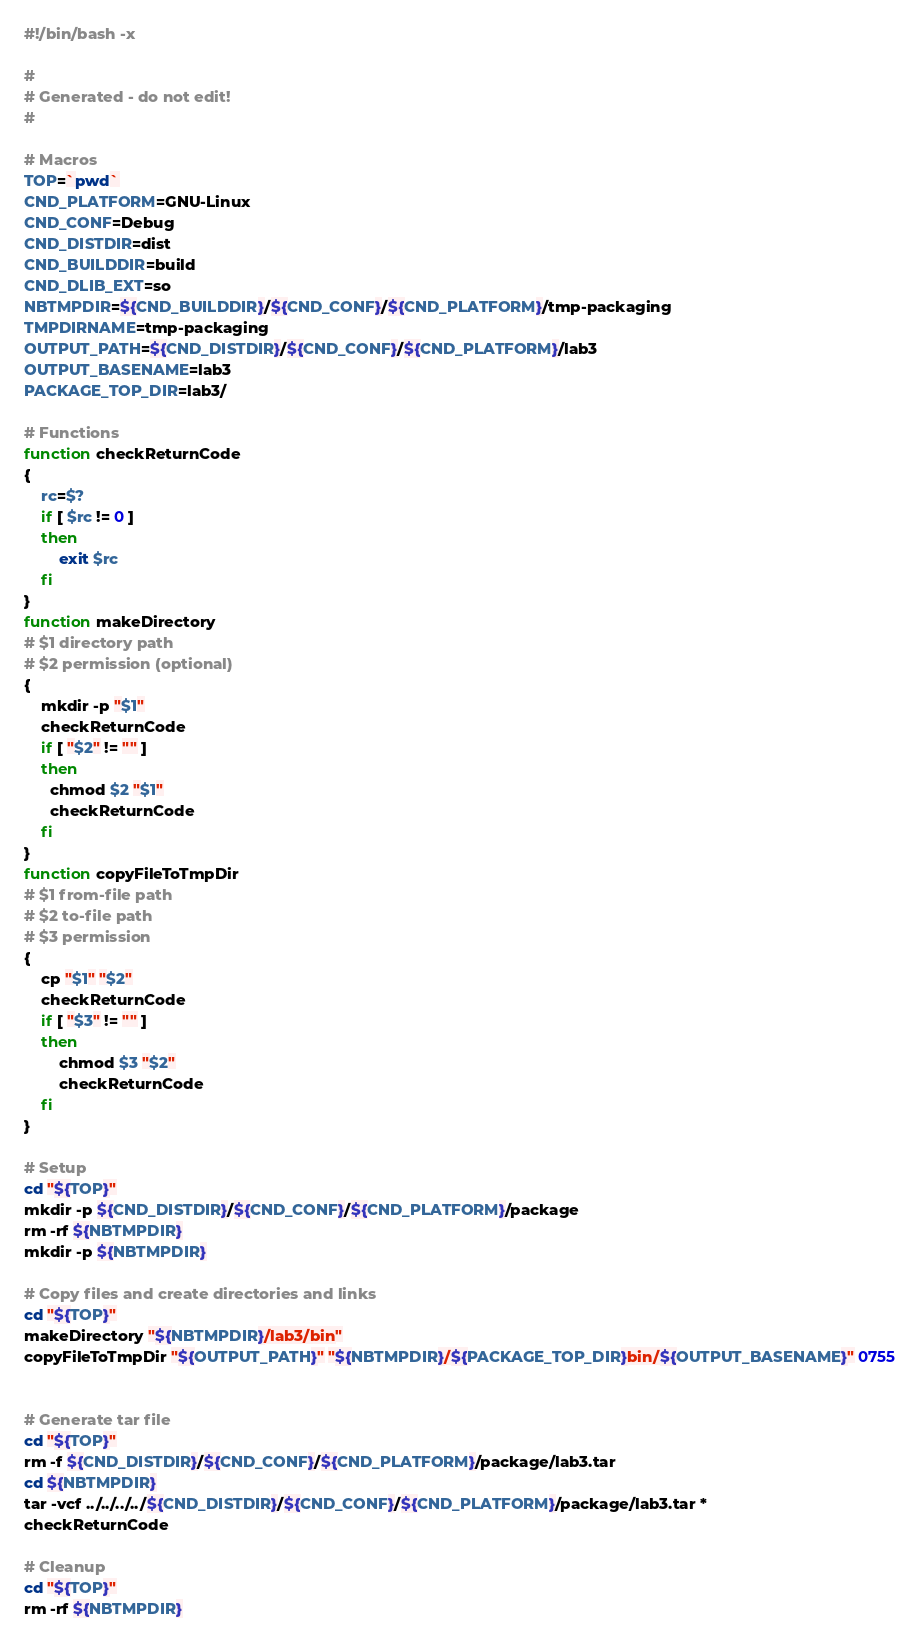<code> <loc_0><loc_0><loc_500><loc_500><_Bash_>#!/bin/bash -x

#
# Generated - do not edit!
#

# Macros
TOP=`pwd`
CND_PLATFORM=GNU-Linux
CND_CONF=Debug
CND_DISTDIR=dist
CND_BUILDDIR=build
CND_DLIB_EXT=so
NBTMPDIR=${CND_BUILDDIR}/${CND_CONF}/${CND_PLATFORM}/tmp-packaging
TMPDIRNAME=tmp-packaging
OUTPUT_PATH=${CND_DISTDIR}/${CND_CONF}/${CND_PLATFORM}/lab3
OUTPUT_BASENAME=lab3
PACKAGE_TOP_DIR=lab3/

# Functions
function checkReturnCode
{
    rc=$?
    if [ $rc != 0 ]
    then
        exit $rc
    fi
}
function makeDirectory
# $1 directory path
# $2 permission (optional)
{
    mkdir -p "$1"
    checkReturnCode
    if [ "$2" != "" ]
    then
      chmod $2 "$1"
      checkReturnCode
    fi
}
function copyFileToTmpDir
# $1 from-file path
# $2 to-file path
# $3 permission
{
    cp "$1" "$2"
    checkReturnCode
    if [ "$3" != "" ]
    then
        chmod $3 "$2"
        checkReturnCode
    fi
}

# Setup
cd "${TOP}"
mkdir -p ${CND_DISTDIR}/${CND_CONF}/${CND_PLATFORM}/package
rm -rf ${NBTMPDIR}
mkdir -p ${NBTMPDIR}

# Copy files and create directories and links
cd "${TOP}"
makeDirectory "${NBTMPDIR}/lab3/bin"
copyFileToTmpDir "${OUTPUT_PATH}" "${NBTMPDIR}/${PACKAGE_TOP_DIR}bin/${OUTPUT_BASENAME}" 0755


# Generate tar file
cd "${TOP}"
rm -f ${CND_DISTDIR}/${CND_CONF}/${CND_PLATFORM}/package/lab3.tar
cd ${NBTMPDIR}
tar -vcf ../../../../${CND_DISTDIR}/${CND_CONF}/${CND_PLATFORM}/package/lab3.tar *
checkReturnCode

# Cleanup
cd "${TOP}"
rm -rf ${NBTMPDIR}
</code> 